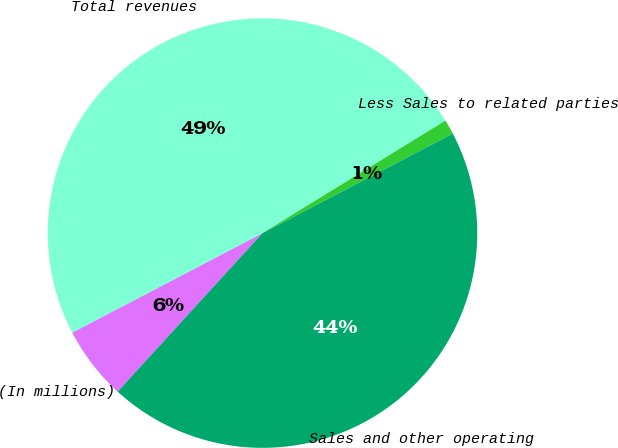Convert chart. <chart><loc_0><loc_0><loc_500><loc_500><pie_chart><fcel>(In millions)<fcel>Total revenues<fcel>Less Sales to related parties<fcel>Sales and other operating<nl><fcel>5.55%<fcel>48.89%<fcel>1.11%<fcel>44.45%<nl></chart> 